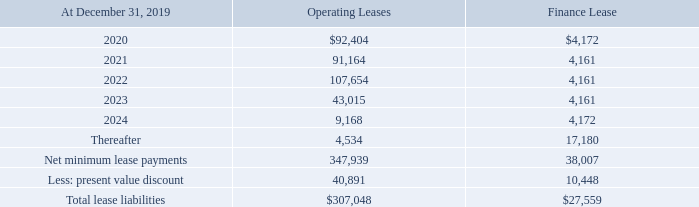Charters-in
As of December 31, 2019, the Company had commitments to charter-in 11 vessels, which are all bareboat charters. During the second quarter of 2019, the Company commenced a bareboat charter for the Overseas Key West for a lease term of 10 years. Based on the length of the lease term and the remaining economic life of the vessel, it is accounted for as a finance lease. The remaining 10 chartered-in vessels are accounted for as operating leases.
The right-of-use asset accounted for as a finance lease arrangement is reported in vessels and other property, less accumulated depreciation on our consolidated balance sheets. The Company holds options for 10 of the vessels chartered-in that can be exercised for one, three or five years with the one-year option only usable once, while the three- and five-year options are available indefinitely.
The lease payments for the charters-in are fixed throughout the option periods and the options are on a vessel-by-vessel basis that can be exercised individually. The Company exercised its option on one of its vessels to extend the term until June 2025. On December 10, 2018, the Company exercised its options to extend the terms of the other nine vessels.
Terms for five of the vessels were extended for an additional three years, with terms ending in December 2022, and terms for four of the vessels were extended for an additional year, with terms ending December 2020. On December 11, 2019, the terms for the four vessels ending December 2020 were extended for an additional three years, with terms ending in December 2023.
Five of the Company's chartered in vessels contain a deferred payment obligation (“DPO”) which relates to charter hire expense incurred by the Company in prior years and payable to the vessel owner in future periods. This DPO is due in quarterly installments with the final quarterly payment due upon lease termination.
The future minimum commitments under these leases are as follows:
The bareboat charters-in provide for variable lease payments in the form of profit share to the owners of the vessels calculated in accordance with the respective charter agreements or based on time charter sublease revenue. Because such amounts and the periods impacted are not reasonably estimable, they are not currently reflected in the table above. Due to reserve funding requirements and current rate forecasts, no profits are currently expected to be paid to the owners in respect of the charter term within the next year.
For the year ended December 31, 2019, lease expense for the 10 chartered-in vessels accounted for as operating leases was $90,359, which is included in charter hire expense on the consolidated statements of operations and operating cash flows on the consolidated statements of cash flows. The Company recognized sublease income of $188,163 for the year ended December 31, 2019.
For the year ended December 31, 2019, the Company had non-cash operating activities of $93,407 for obtaining operating right-of-use assets and liabilities that resulted from exercising lease renewals not assumed in the initial lease term.
For the year ended December 31, 2019, lease expense related to the Company's finance lease was $2,052 related to amortization of the right-of-use asset and $1,462 related to interest on the lease liability. These are included in operating cash flows on the consolidated statements of cash flows. For the year ended December 31, 2019, the Company had non-cash financing activities of $28,993 for obtaining finance right-of-use assets.
For the year ended December 31, 2018, lease expense relating to charters-in was $91,350, which is included in charter hire expense on the consolidated statements of operations.
How much was the lease expense relating to charters-in for the year ended December 31, 2018? $91,350. What is the change in future minimum commitments of Operating Leases from 2020 to 2021? 91,164-92,404
Answer: -1240. What is the average future minimum commitments of Operating Leases for 2020 to 2021? (91,164+92,404) / 2
Answer: 91784. In which year was Operating Leases greater than 100,000? Locate and analyze operating leases in column 3
answer: 2022. What was the Finance Lease in 2020 and 2021 respectively? $4,172, 4,161. What was the Finance Lease in 2022 and 2023 respectively? 4,161, 4,161. 